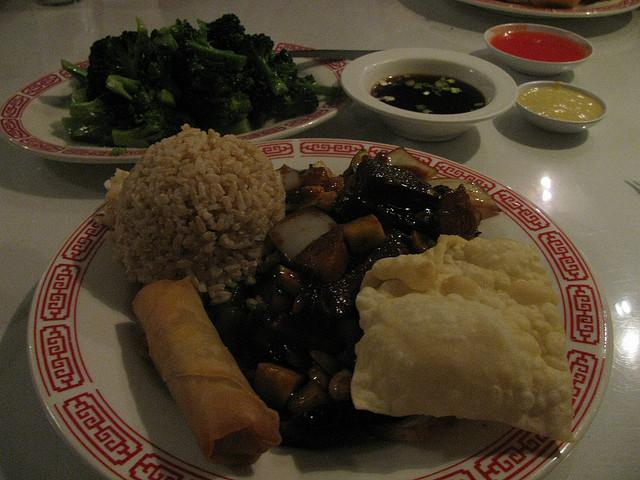What is used to sook the food? oil 